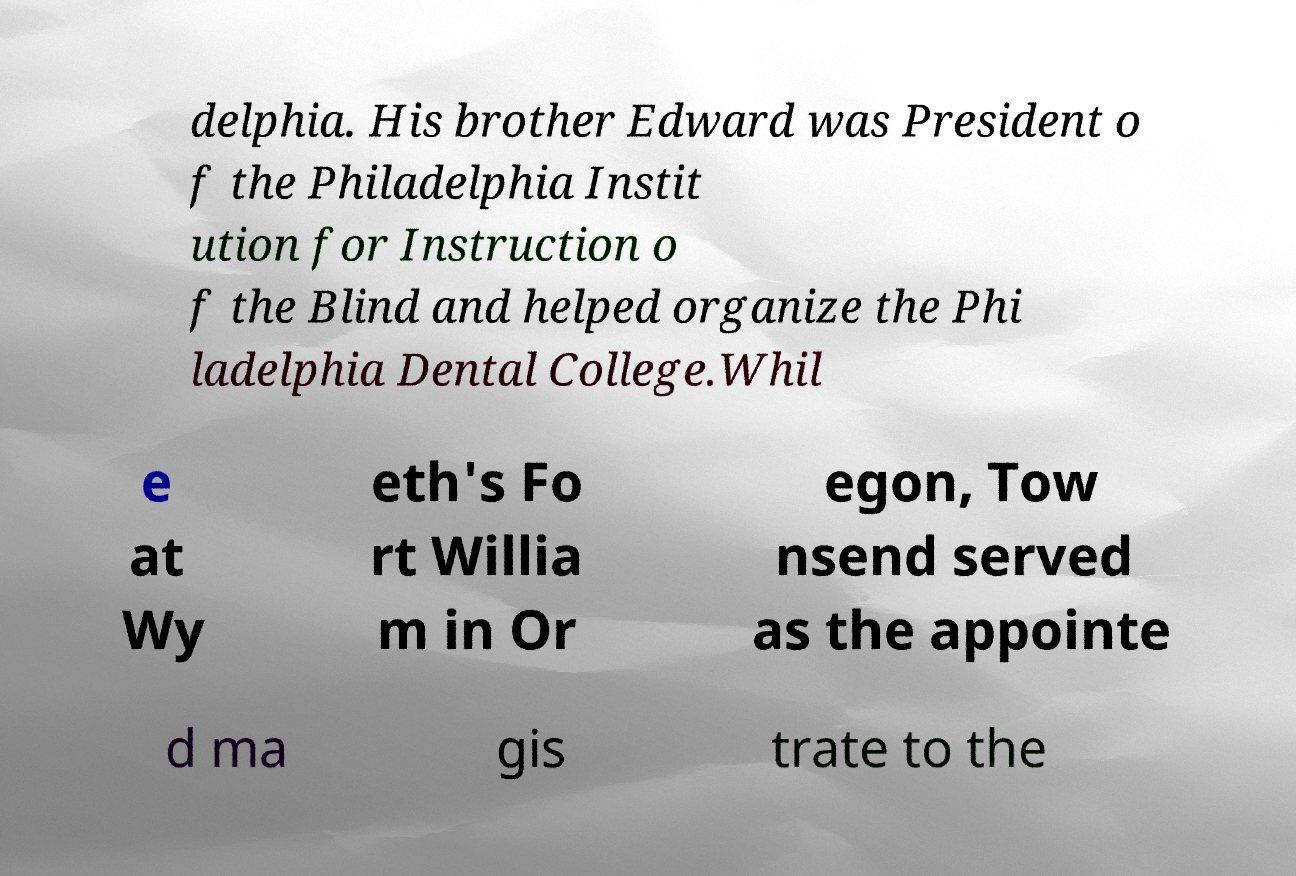Please identify and transcribe the text found in this image. delphia. His brother Edward was President o f the Philadelphia Instit ution for Instruction o f the Blind and helped organize the Phi ladelphia Dental College.Whil e at Wy eth's Fo rt Willia m in Or egon, Tow nsend served as the appointe d ma gis trate to the 